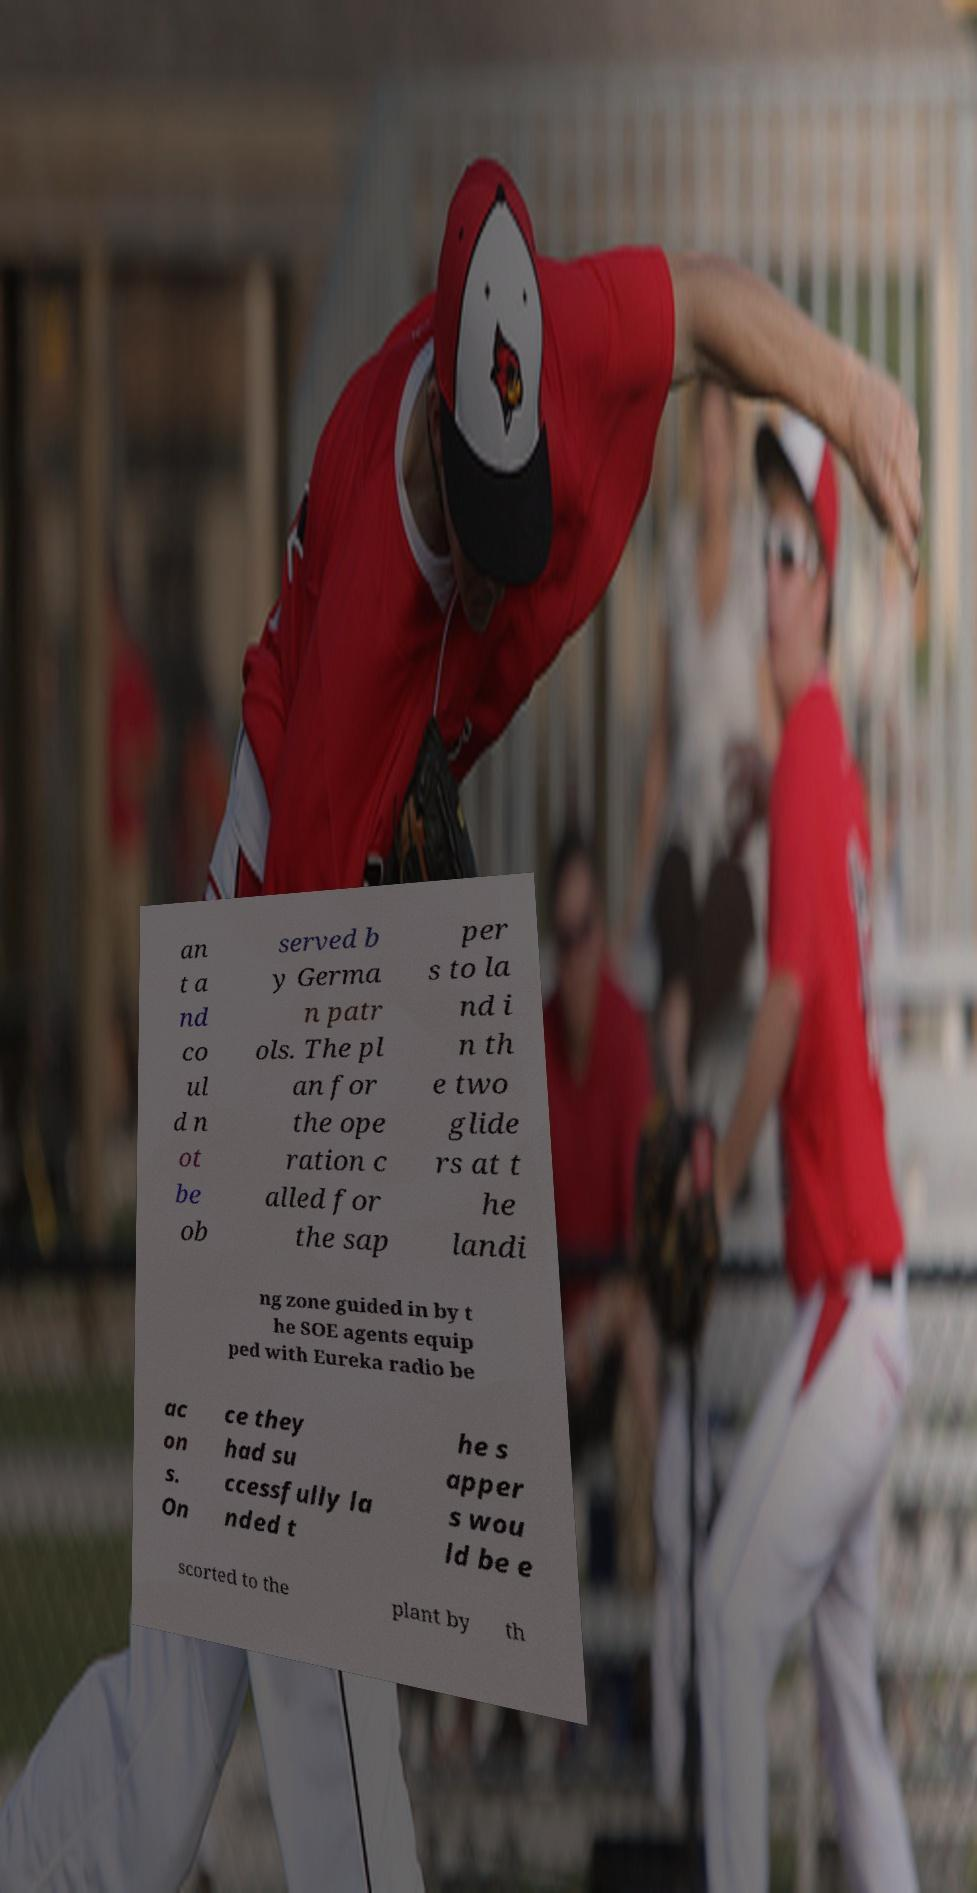Can you read and provide the text displayed in the image?This photo seems to have some interesting text. Can you extract and type it out for me? an t a nd co ul d n ot be ob served b y Germa n patr ols. The pl an for the ope ration c alled for the sap per s to la nd i n th e two glide rs at t he landi ng zone guided in by t he SOE agents equip ped with Eureka radio be ac on s. On ce they had su ccessfully la nded t he s apper s wou ld be e scorted to the plant by th 